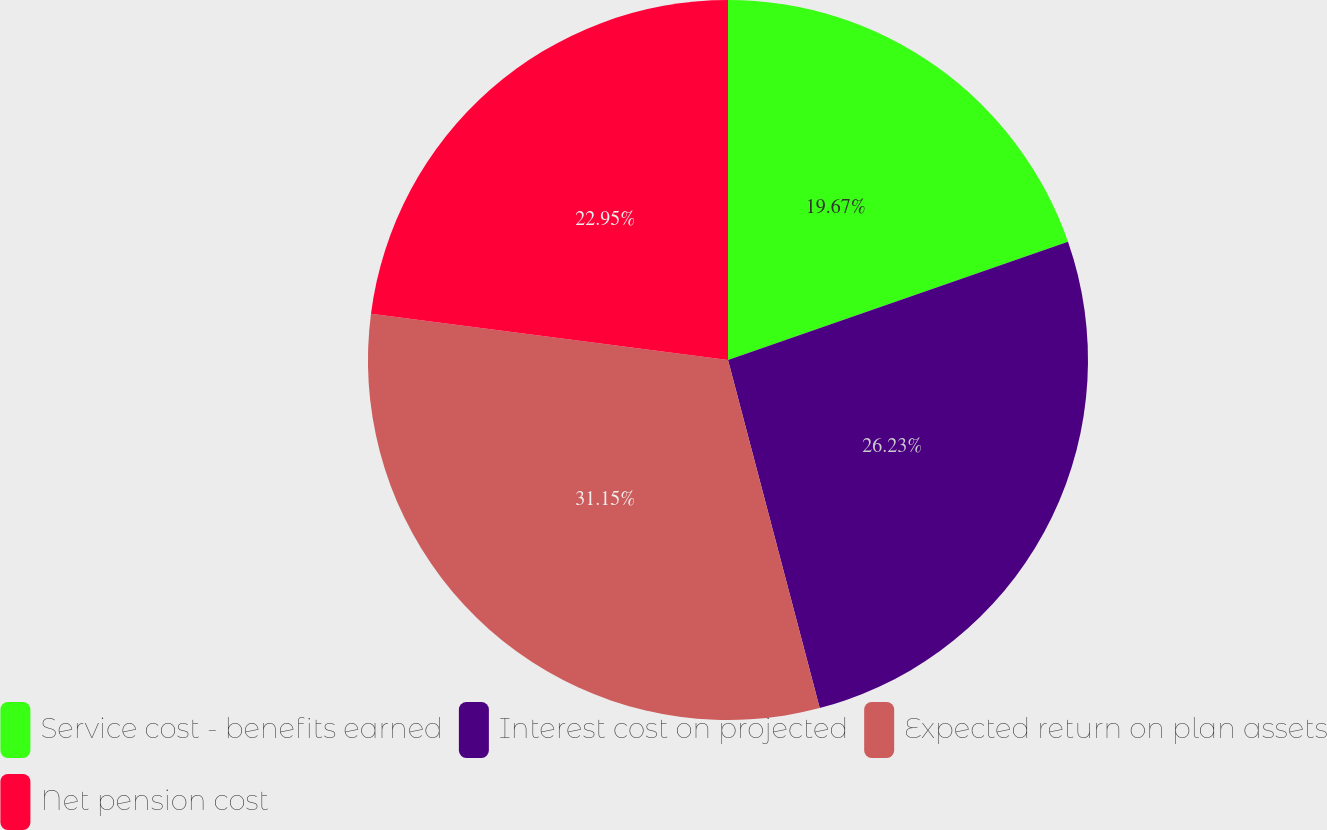<chart> <loc_0><loc_0><loc_500><loc_500><pie_chart><fcel>Service cost - benefits earned<fcel>Interest cost on projected<fcel>Expected return on plan assets<fcel>Net pension cost<nl><fcel>19.67%<fcel>26.23%<fcel>31.15%<fcel>22.95%<nl></chart> 